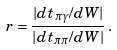<formula> <loc_0><loc_0><loc_500><loc_500>r = \frac { | d t _ { \pi \gamma } / d W | } { | d t _ { \pi \pi } / d W | } \, .</formula> 